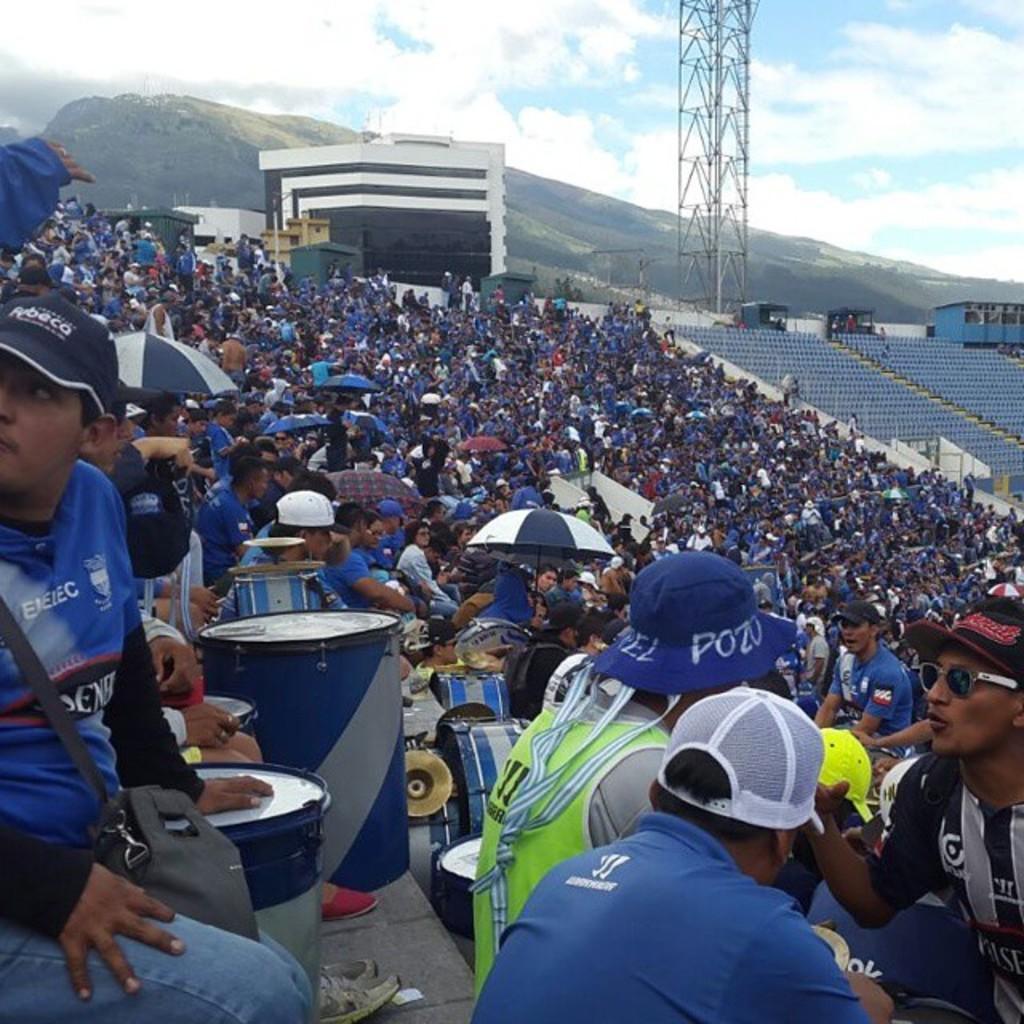In one or two sentences, can you explain what this image depicts? In this picture I can see there are audience here and there is a tower and mountain in the backdrop. 